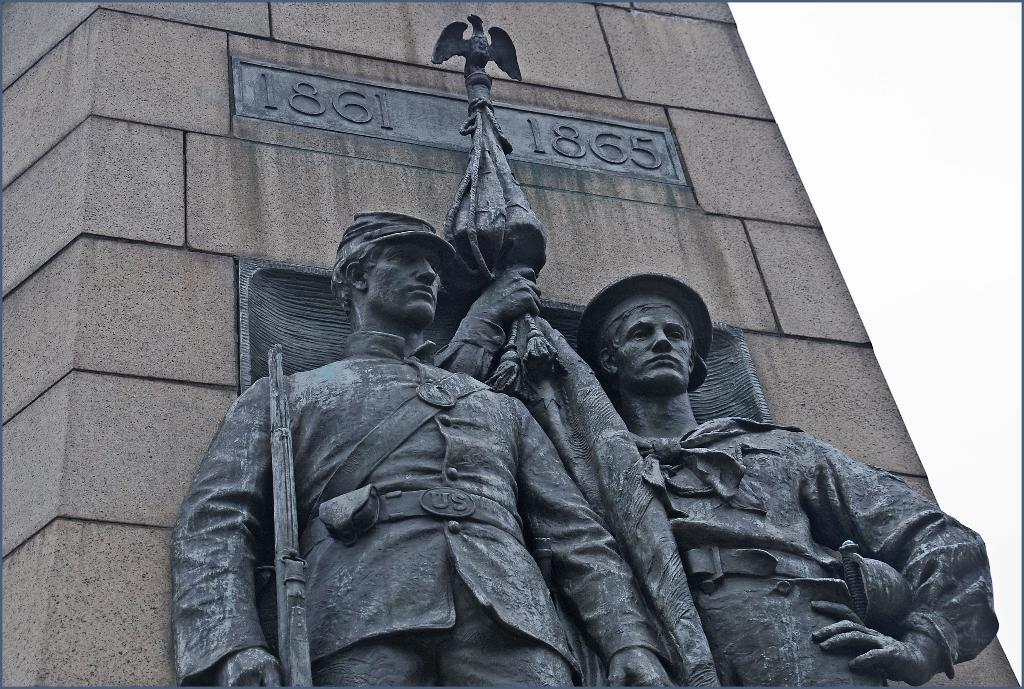How many statues are present in the image? There are two statues in the image. Can you describe the statues in the image? Unfortunately, the provided facts do not include any details about the appearance or characteristics of the statues. What is visible in the background of the image? There is a wall in the background of the image. What type of hen is sitting on the doctor's shoulder in the image? There is no hen or doctor present in the image; it only features two statues and a wall in the background. 